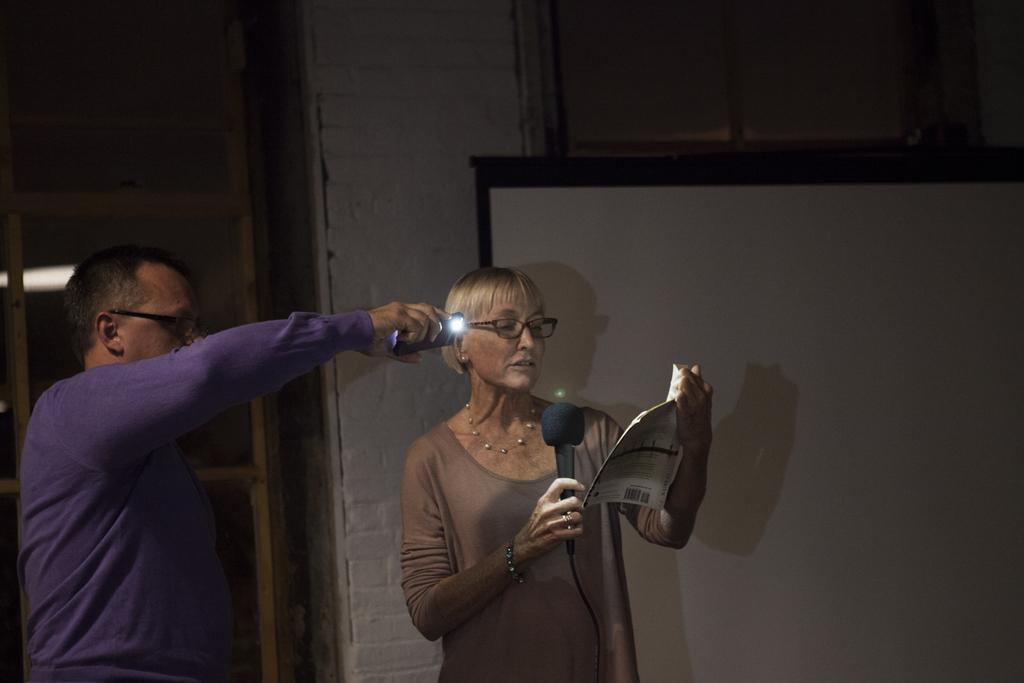How many people are present in the image? There are two people in the image, a man and a woman. What is the woman holding in the image? The woman is holding a book. What is the man holding in the image? The man is holding a phone. What accessory do both the man and the woman have in common? Both the man and the woman are wearing glasses. What type of stick can be seen in the image? There is no stick present in the image. What role does the calculator play in the image? There is no calculator present in the image. 